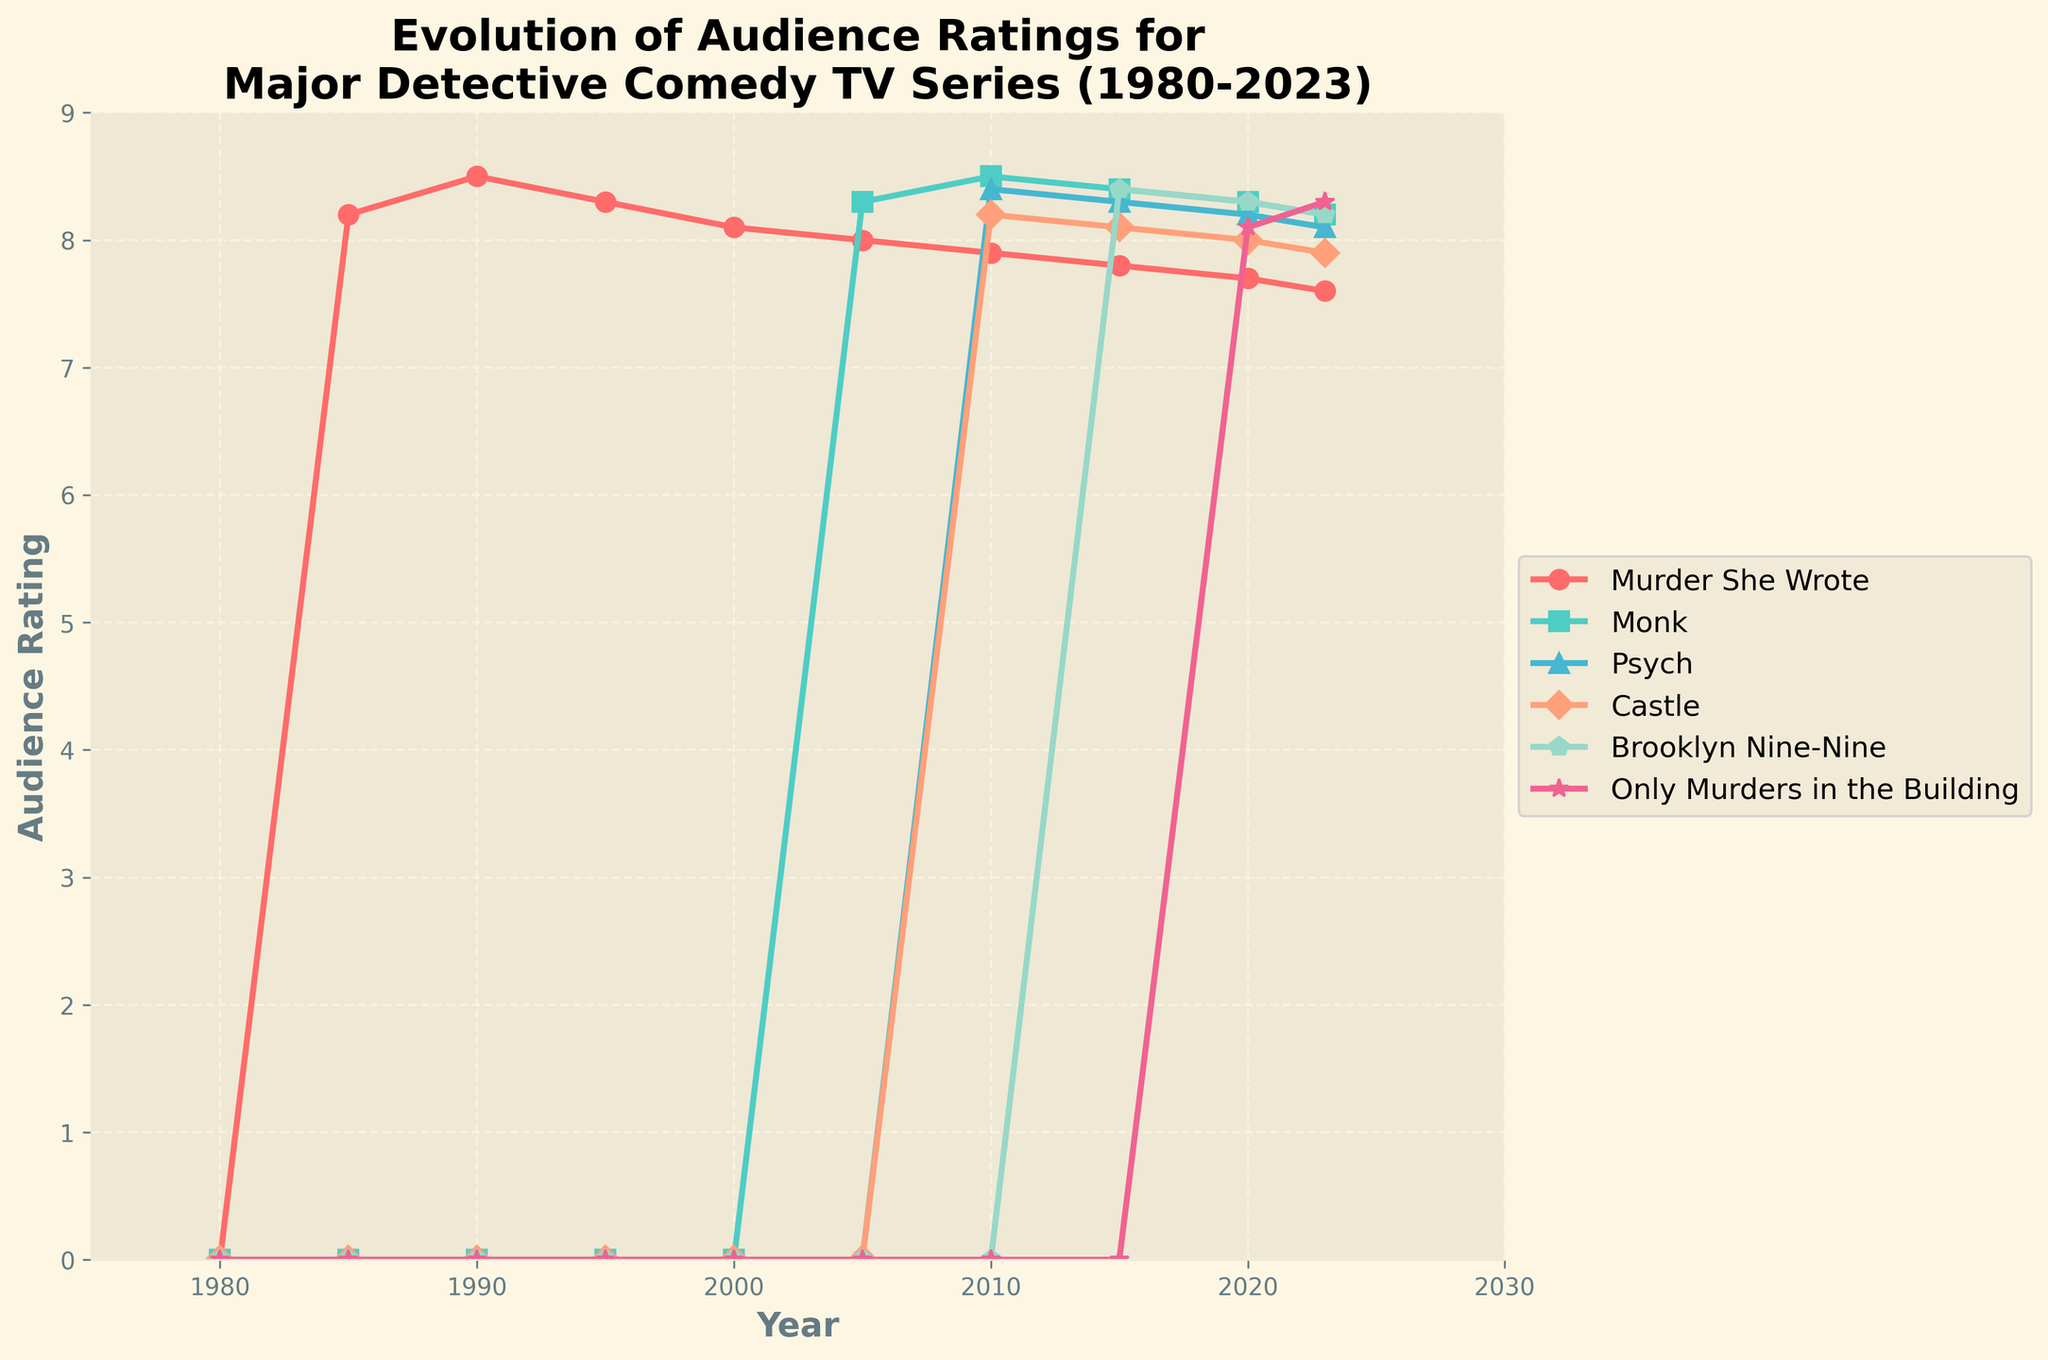Which series had the highest audience rating in 2020? To find the series with the highest audience rating in 2020, check the ratings for all series in that year. "Brooklyn Nine-Nine" has the highest rating of 8.3 in 2020.
Answer: Brooklyn Nine-Nine How did the ratings of "Murder She Wrote" change from 1985 to 2000? Look at the ratings of "Murder She Wrote" in 1985 and 2000. The rating decreased from 8.2 in 1985 to 8.1 in 2000 with fluctuations in between.
Answer: Decreased slightly Which series showed a continuous decline in ratings from their peak? Check each series' ratings over time and identify any series that continuously declined after reaching its peak. "Murder She Wrote" shows a continuous decline from 8.5 in 1990 to 7.6 in 2023.
Answer: Murder She Wrote In 2010, which two series had almost the same audience rating, and what were their ratings? Compare the ratings of all series in 2010. "Monk" and "Psych" both had ratings that were very close to each other, 8.5 and 8.4 respectively.
Answer: Monk and Psych, 8.5 and 8.4 Which series experienced a steady rise and then a fall in ratings, and during what period did this occur? Look for series with trends that include both a rise and subsequent fall. "Monk" experienced a steady rise from 2005 (8.3) to 2010 (8.5) and then a fall to 2023 (8.2).
Answer: Monk, 2005 to 2023 What is the average rating of "Only Murders in the Building" from 2020 to 2023? Calculate the sum of the ratings of "Only Murders in the Building" from 2020 (8.1) and 2023 (8.3) and divide by the number of years. (8.1 + 8.3) / 2 = 8.2
Answer: 8.2 Which series has maintained a consistent rating with the least fluctuations since its debut? Compare the rating changes over time for each series. "Brooklyn Nine-Nine" has maintained a consistent rating, ranging narrowly from 8.4 in 2015 to 8.2 in 2023.
Answer: Brooklyn Nine-Nine From 1985 to 1990, which series had the highest rating gain, and what was the difference? Look at the differences in ratings for each series from 1985 to 1990. "Murder She Wrote" had the highest gain from 8.2 to 8.5, a difference of 0.3.
Answer: Murder She Wrote, 0.3 